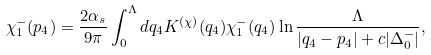<formula> <loc_0><loc_0><loc_500><loc_500>\chi _ { 1 } ^ { - } ( p _ { 4 } ) = \frac { 2 \alpha _ { s } } { 9 \pi } \int _ { 0 } ^ { \Lambda } d q _ { 4 } K ^ { ( \chi ) } ( q _ { 4 } ) \chi ^ { - } _ { 1 } ( q _ { 4 } ) \ln \frac { \Lambda } { | q _ { 4 } - p _ { 4 } | + c | \Delta ^ { - } _ { 0 } | } ,</formula> 